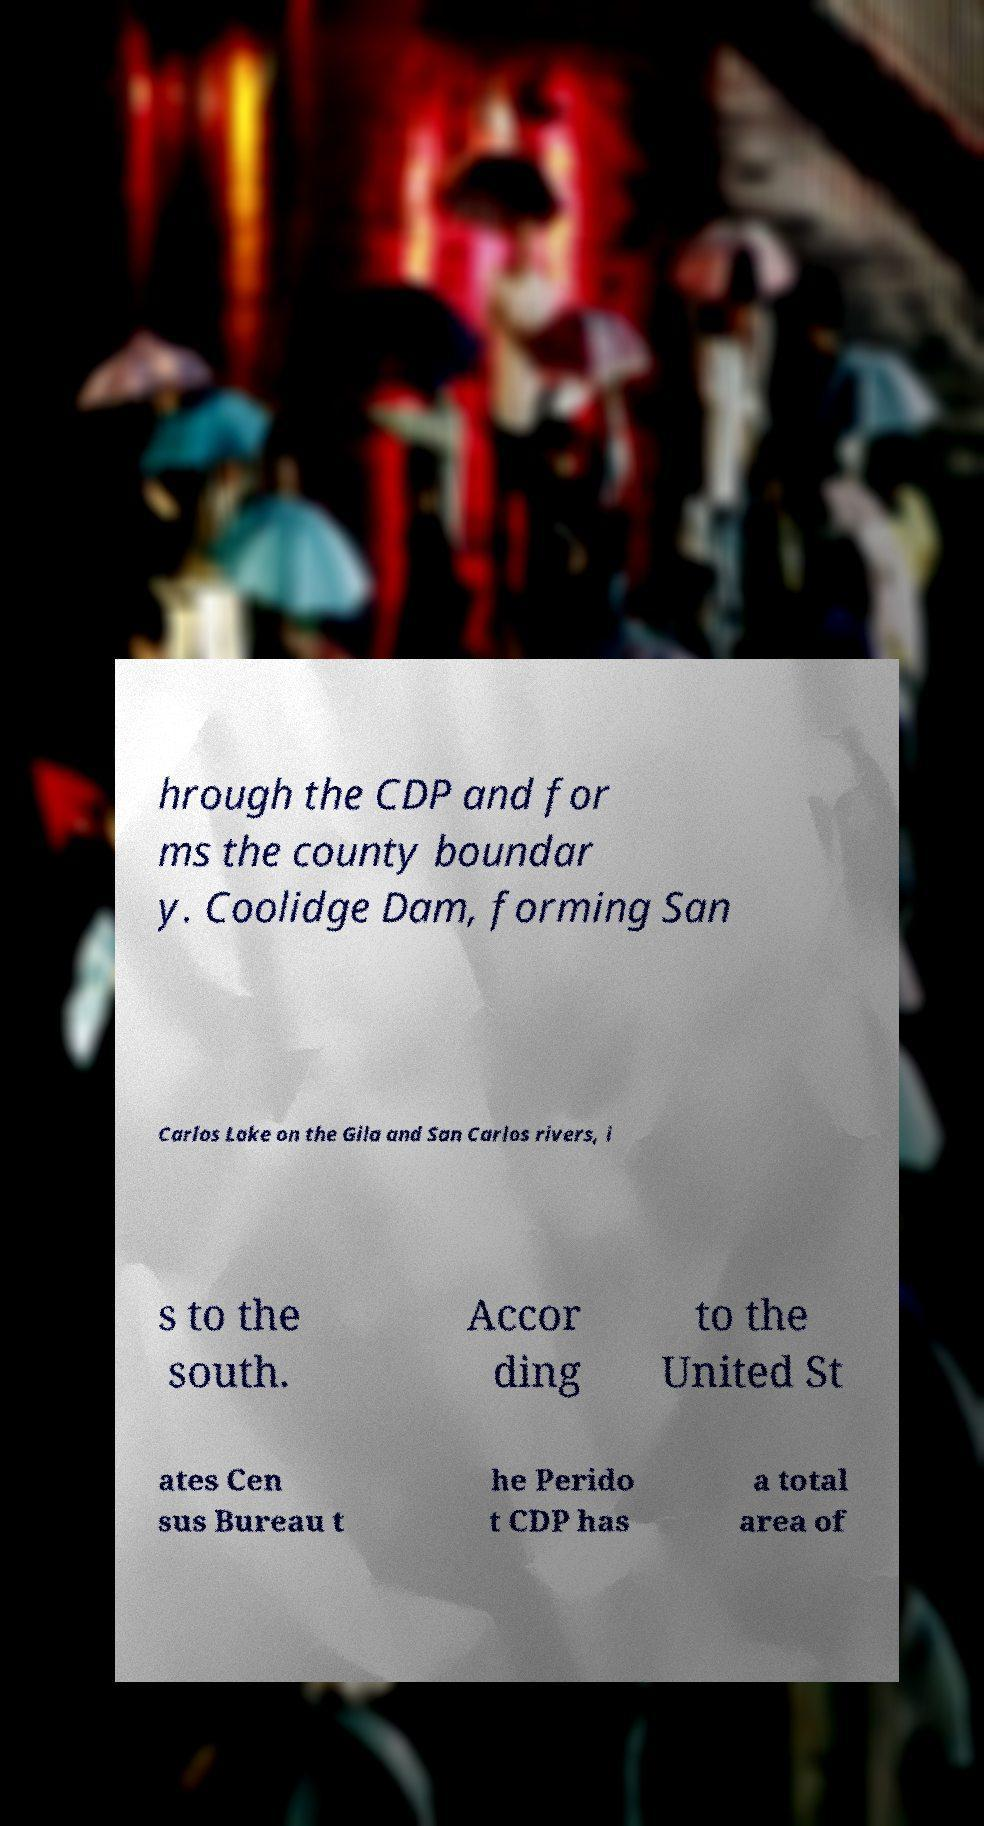Can you read and provide the text displayed in the image?This photo seems to have some interesting text. Can you extract and type it out for me? hrough the CDP and for ms the county boundar y. Coolidge Dam, forming San Carlos Lake on the Gila and San Carlos rivers, i s to the south. Accor ding to the United St ates Cen sus Bureau t he Perido t CDP has a total area of 